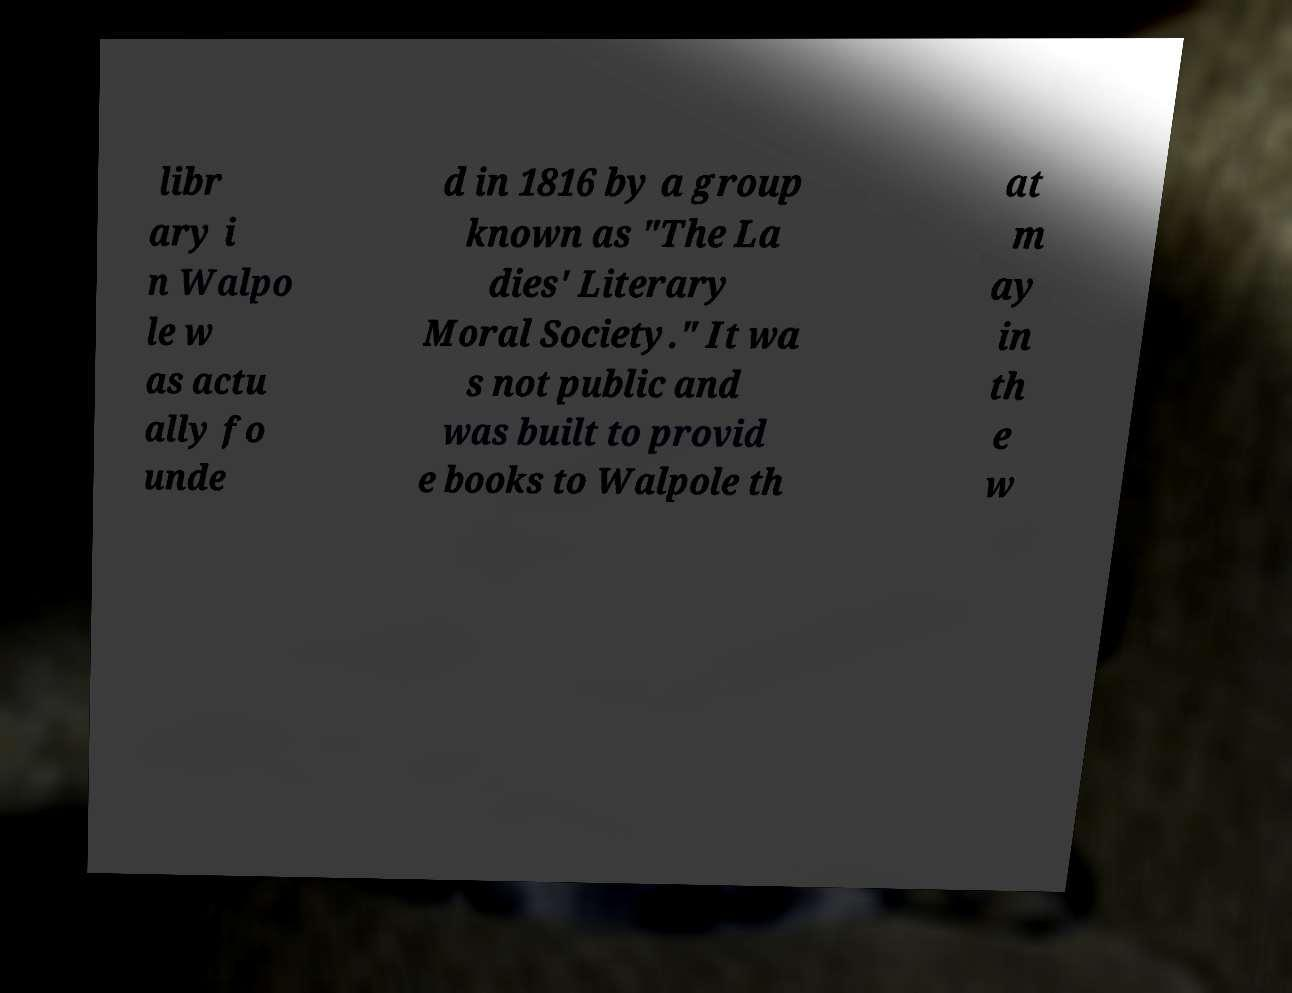Can you accurately transcribe the text from the provided image for me? libr ary i n Walpo le w as actu ally fo unde d in 1816 by a group known as "The La dies' Literary Moral Society." It wa s not public and was built to provid e books to Walpole th at m ay in th e w 